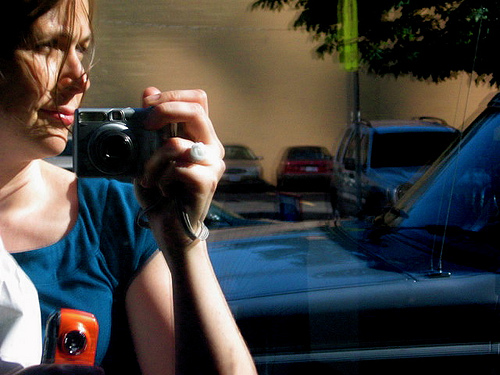Can you tell me what time of day this picture might have been taken and why? Based on the image, it appears to have been taken during the day, judging from the bright natural lighting and the clear shadows cast by the person and objects, suggesting sunlight is present. 